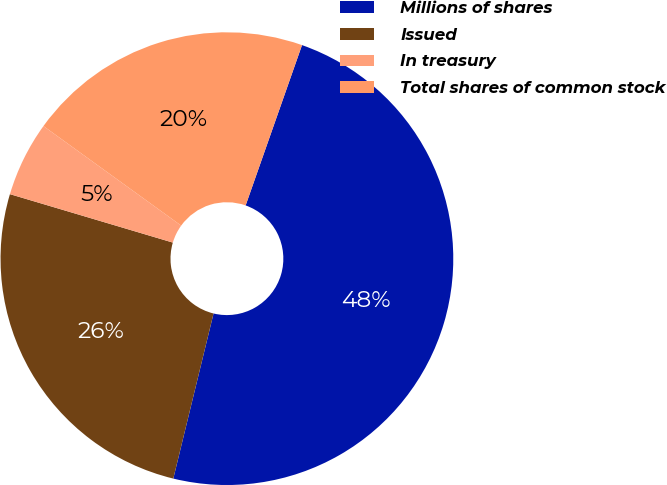Convert chart to OTSL. <chart><loc_0><loc_0><loc_500><loc_500><pie_chart><fcel>Millions of shares<fcel>Issued<fcel>In treasury<fcel>Total shares of common stock<nl><fcel>48.42%<fcel>25.79%<fcel>5.36%<fcel>20.42%<nl></chart> 